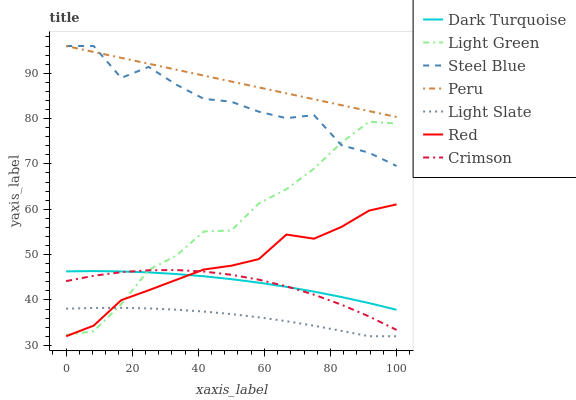Does Dark Turquoise have the minimum area under the curve?
Answer yes or no. No. Does Dark Turquoise have the maximum area under the curve?
Answer yes or no. No. Is Light Slate the smoothest?
Answer yes or no. No. Is Light Slate the roughest?
Answer yes or no. No. Does Dark Turquoise have the lowest value?
Answer yes or no. No. Does Dark Turquoise have the highest value?
Answer yes or no. No. Is Light Green less than Peru?
Answer yes or no. Yes. Is Crimson greater than Light Slate?
Answer yes or no. Yes. Does Light Green intersect Peru?
Answer yes or no. No. 